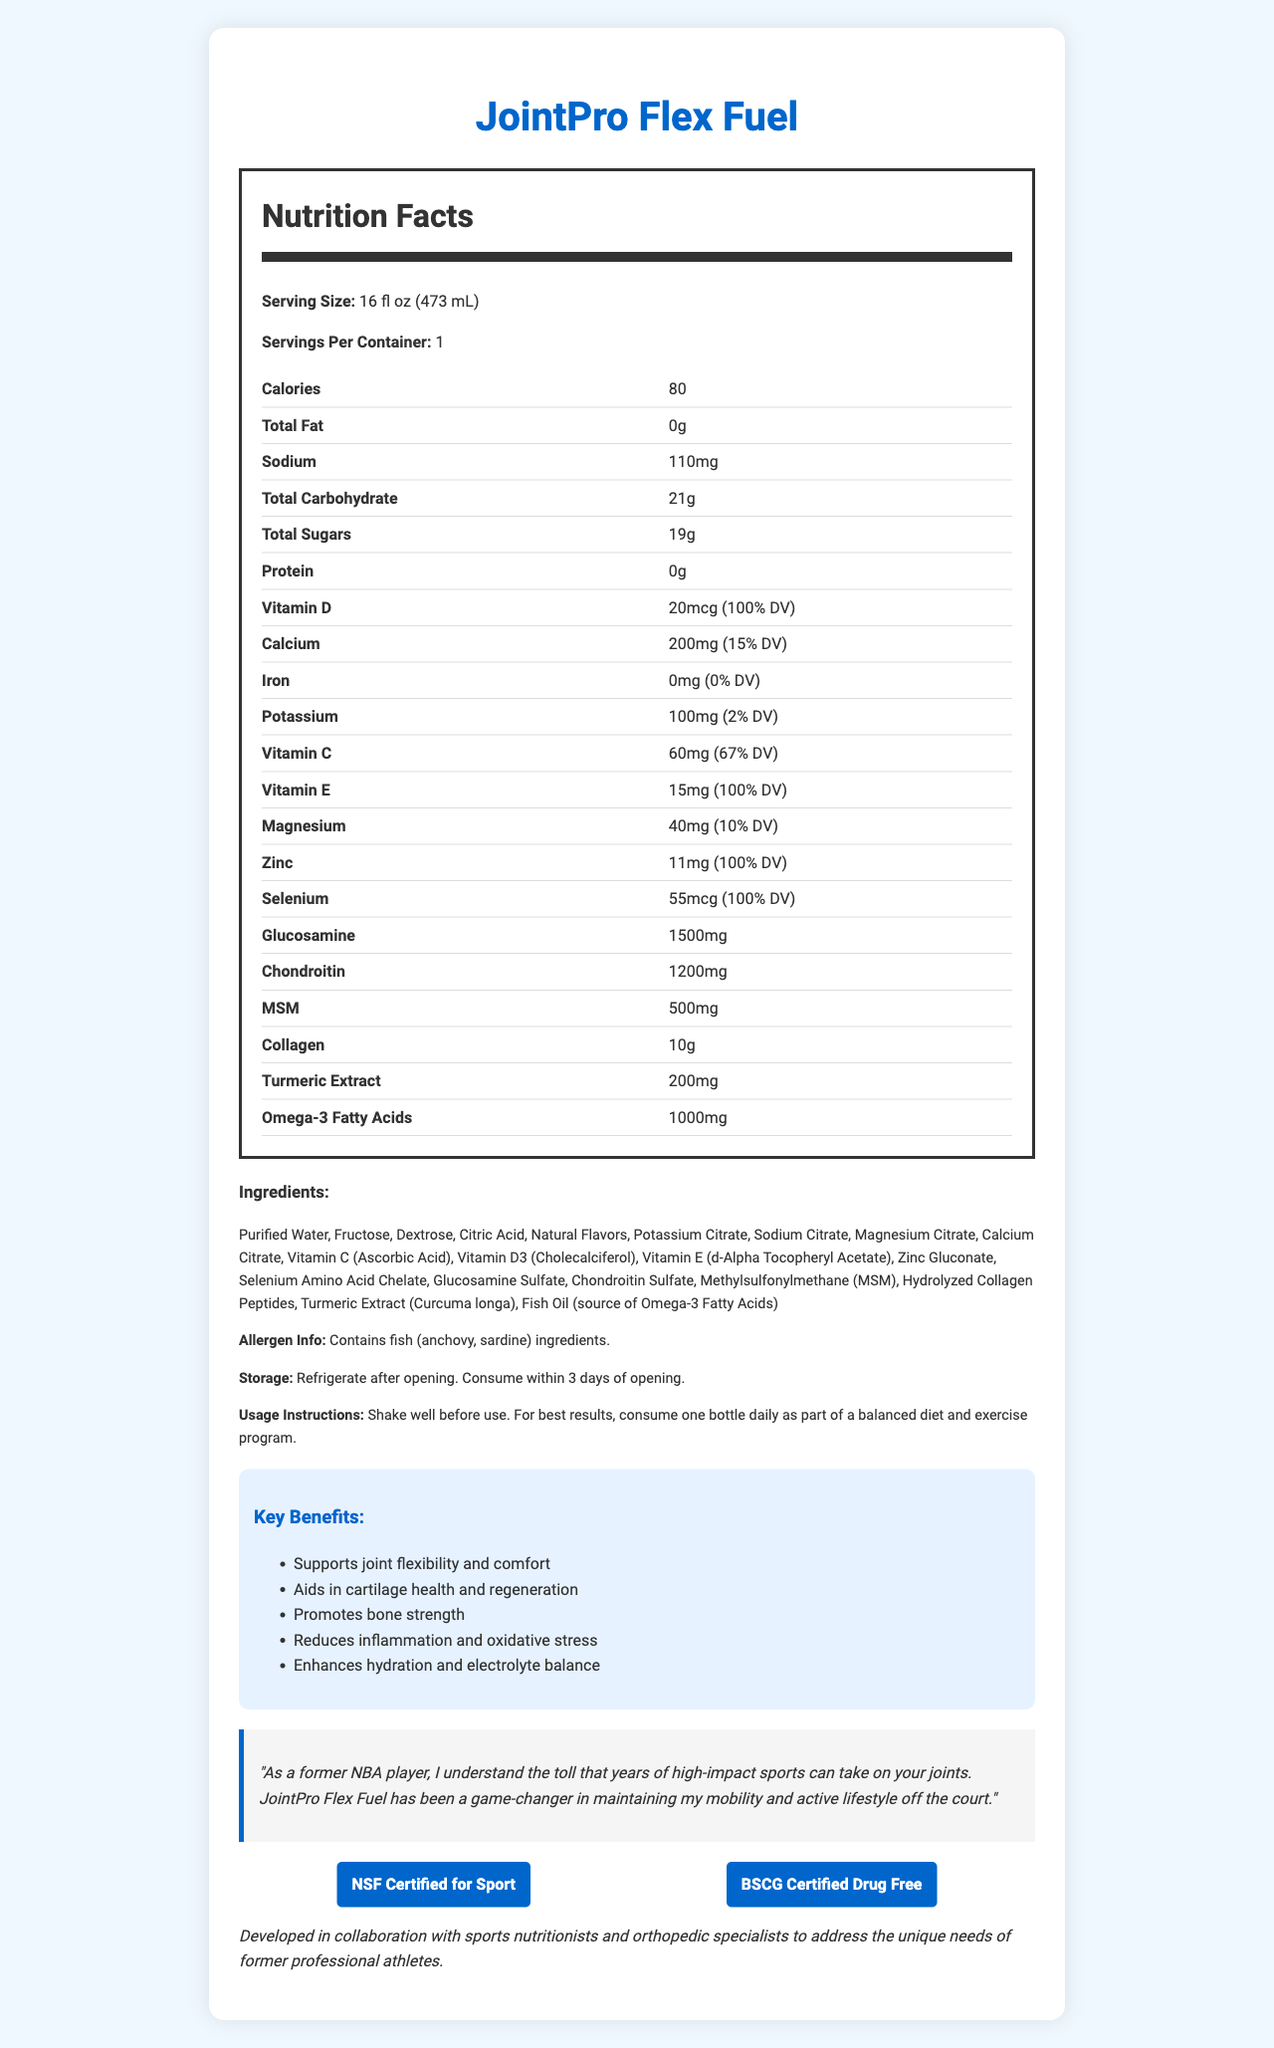what is the serving size of JointPro Flex Fuel? The serving size is clearly specified in the Nutrition Facts section as 16 fl oz (473 mL).
Answer: 16 fl oz (473 mL) how many calories are in one serving of JointPro Flex Fuel? The Nutrition Facts label lists the total calories per serving as 80.
Answer: 80 what is the amount of Vitamin D in a serving of JointPro Flex Fuel? The Nutrition Facts section shows that one serving contains 20mcg of Vitamin D, which is also 100% of the daily value.
Answer: 20mcg (100% DV) what are the total sugars in one serving? The Nutrition Facts label indicates that the total sugars amount to 19g per serving.
Answer: 19g how many milligrams of magnesium are in each serving? The Nutrition Facts section details that each serving contains 40mg of magnesium, which is 10% of the daily value.
Answer: 40mg (10% DV) how much protein is in the product? The Nutrition Facts label states that there is 0g of protein per serving.
Answer: 0g what is the total carbohydrate content per serving? The total carbohydrate content is listed as 21g in the Nutrition Facts section.
Answer: 21g how much collagen is included in a serving? The document specifies that one serving contains 10g of collagen.
Answer: 10g Which of the following minerals is NOT in JointPro Flex Fuel? A. Calcium B. Iron C. Zinc D. Magnesium The Nutrition Facts show that Iron is listed as 0mg (0% DV), meaning it is effectively not present in the product.
Answer: B Which certification does JointPro Flex Fuel have? A. FSSC 22000 B. NSF Certified for Sport C. USD Organic D. kosher The document states that JointPro Flex Fuel is "NSF Certified for Sport" and "BSCG Certified Drug Free".
Answer: B Does the product contain allergens? The allergen information section mentions that the product contains fish (anchovy, sardine) ingredients.
Answer: Yes Can you describe the key benefits of JointPro Flex Fuel? The benefits section details these five key benefits.
Answer: Supports joint flexibility and comfort, Aids in cartilage health and regeneration, Promotes bone strength, Reduces inflammation and oxidative stress, Enhances hydration and electrolyte balance Is the product designed only for current athletes? According to the document, the target audience includes "former athletes and active individuals over 40 looking to support joint health and mobility".
Answer: No What is the storage instruction for this sports drink? The document clearly states that after opening, the product should be refrigerated and consumed within 3 days.
Answer: Refrigerate after opening. Consume within 3 days of opening. What are the main ingredients in JointPro Flex Fuel? The ingredients section lists out all these components.
Answer: Purified Water, Fructose, Dextrose, Citric Acid, Natural Flavors, Potassium Citrate, Sodium Citrate, Magnesium Citrate, Calcium Citrate, Vitamin C, Vitamin D3, Vitamin E, Zinc Gluconate, Selenium Amino Acid Chelate, Glucosamine Sulfate, Chondroitin Sulfate, MSM, Hydrolyzed Collagen Peptides, Turmeric Extract, Fish Oil What is the recommended daily usage of JointPro Flex Fuel for best results? The usage instructions recommend consuming one bottle every day as part of a balanced diet and exercise routine.
Answer: Consume one bottle daily as part of a balanced diet and exercise program Describe the entire document or its main idea. The document is a comprehensive description of JointPro Flex Fuel, highlighting its nutritional composition, key benefits, target audience, certifications, and testimonials.
Answer: The document provides detailed nutritional information about JointPro Flex Fuel, a vitamin-fortified sports drink designed to support joint health in former athletes. It includes a breakdown of calories, key vitamins and minerals, ingredients, and allergen information. Benefits for joint health, cartilage regeneration, and hydration are highlighted, backed by certifications. Testimonials and additional usage and storage instructions are also provided. What specific types of fish ingredients are included in this product? The allergen information specifies that the product contains fish ingredients, specifically anchovy and sardine.
Answer: Anchovy, Sardine 